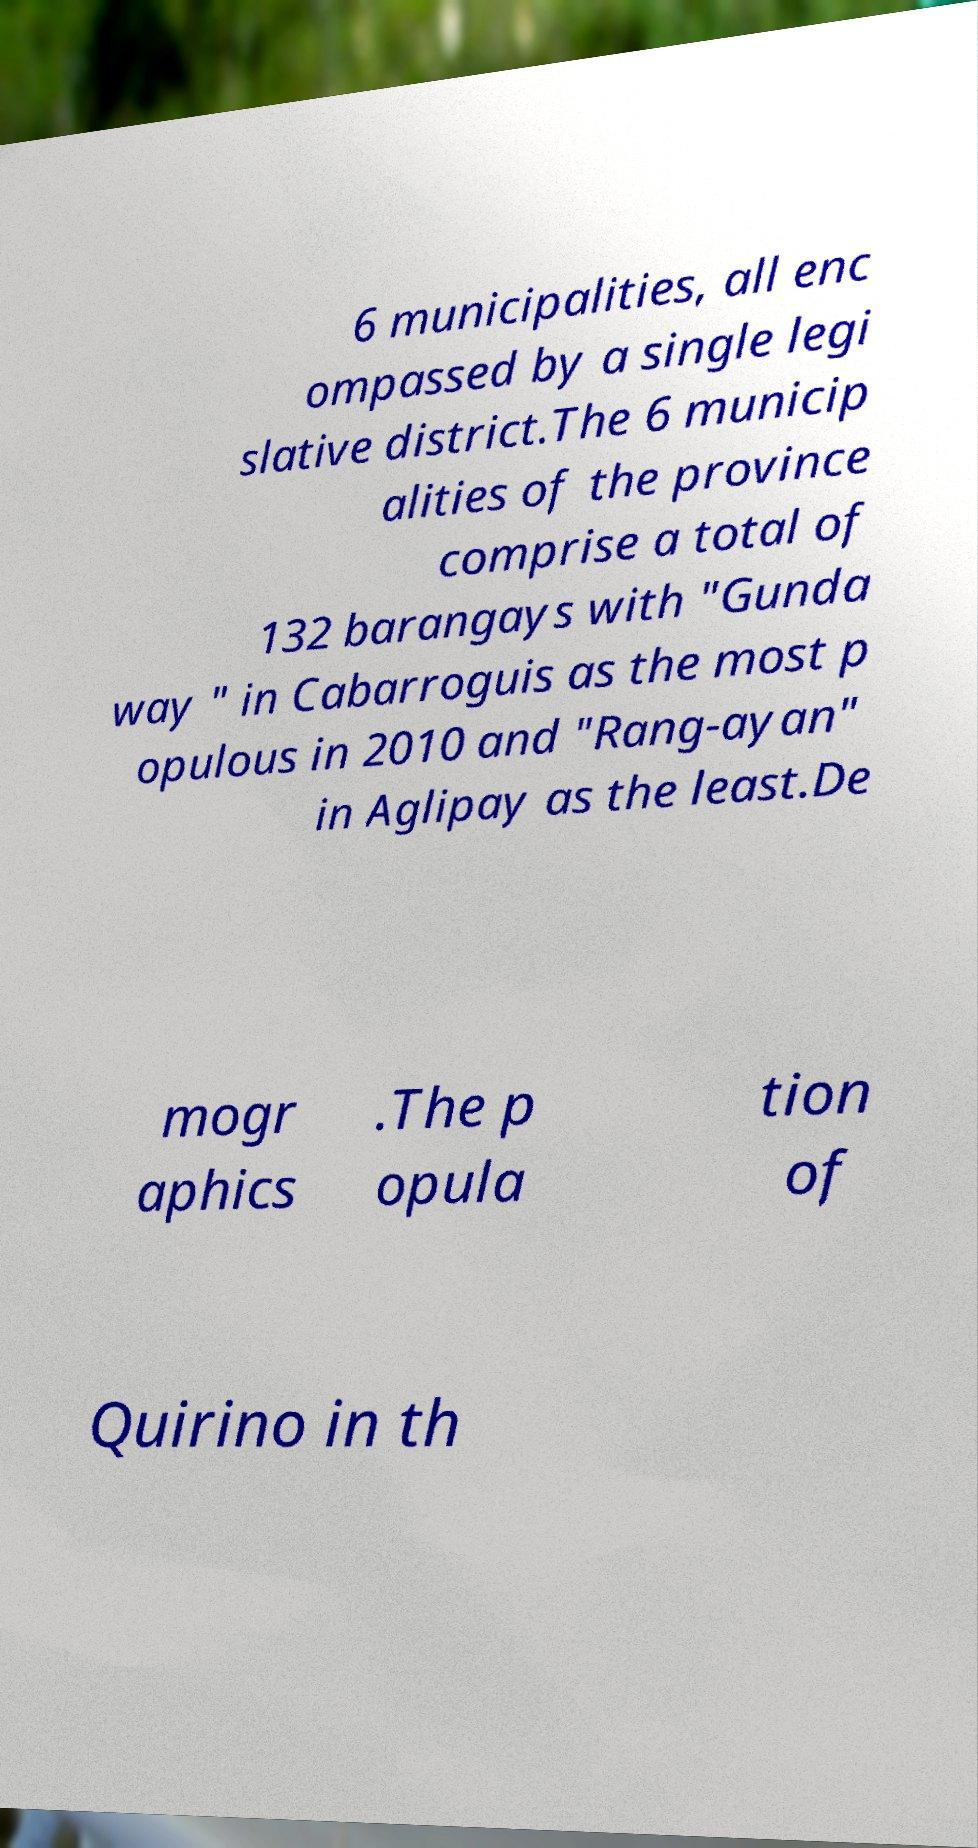What messages or text are displayed in this image? I need them in a readable, typed format. 6 municipalities, all enc ompassed by a single legi slative district.The 6 municip alities of the province comprise a total of 132 barangays with "Gunda way " in Cabarroguis as the most p opulous in 2010 and "Rang-ayan" in Aglipay as the least.De mogr aphics .The p opula tion of Quirino in th 